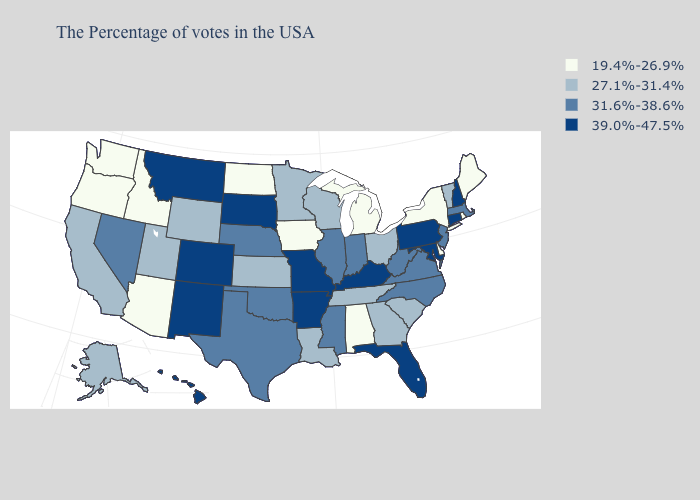Does Rhode Island have the lowest value in the Northeast?
Be succinct. Yes. What is the value of Wyoming?
Quick response, please. 27.1%-31.4%. Name the states that have a value in the range 27.1%-31.4%?
Write a very short answer. Vermont, South Carolina, Ohio, Georgia, Tennessee, Wisconsin, Louisiana, Minnesota, Kansas, Wyoming, Utah, California, Alaska. What is the value of Minnesota?
Be succinct. 27.1%-31.4%. What is the lowest value in the USA?
Short answer required. 19.4%-26.9%. Name the states that have a value in the range 39.0%-47.5%?
Concise answer only. New Hampshire, Connecticut, Maryland, Pennsylvania, Florida, Kentucky, Missouri, Arkansas, South Dakota, Colorado, New Mexico, Montana, Hawaii. Does Alaska have the lowest value in the West?
Short answer required. No. Name the states that have a value in the range 19.4%-26.9%?
Be succinct. Maine, Rhode Island, New York, Delaware, Michigan, Alabama, Iowa, North Dakota, Arizona, Idaho, Washington, Oregon. Name the states that have a value in the range 39.0%-47.5%?
Concise answer only. New Hampshire, Connecticut, Maryland, Pennsylvania, Florida, Kentucky, Missouri, Arkansas, South Dakota, Colorado, New Mexico, Montana, Hawaii. What is the lowest value in states that border New Jersey?
Give a very brief answer. 19.4%-26.9%. Name the states that have a value in the range 19.4%-26.9%?
Keep it brief. Maine, Rhode Island, New York, Delaware, Michigan, Alabama, Iowa, North Dakota, Arizona, Idaho, Washington, Oregon. What is the highest value in the USA?
Quick response, please. 39.0%-47.5%. Name the states that have a value in the range 27.1%-31.4%?
Write a very short answer. Vermont, South Carolina, Ohio, Georgia, Tennessee, Wisconsin, Louisiana, Minnesota, Kansas, Wyoming, Utah, California, Alaska. Name the states that have a value in the range 27.1%-31.4%?
Give a very brief answer. Vermont, South Carolina, Ohio, Georgia, Tennessee, Wisconsin, Louisiana, Minnesota, Kansas, Wyoming, Utah, California, Alaska. Name the states that have a value in the range 39.0%-47.5%?
Be succinct. New Hampshire, Connecticut, Maryland, Pennsylvania, Florida, Kentucky, Missouri, Arkansas, South Dakota, Colorado, New Mexico, Montana, Hawaii. 